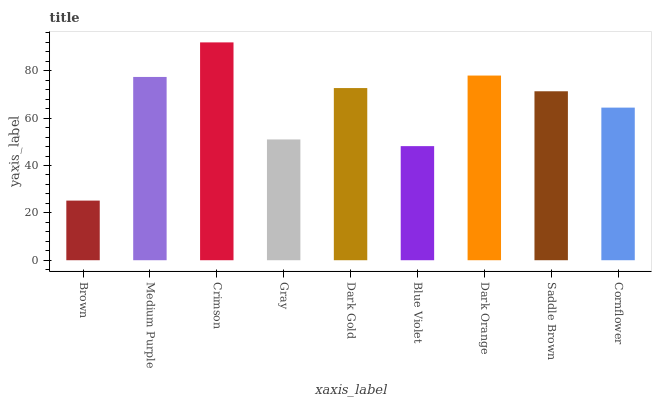Is Brown the minimum?
Answer yes or no. Yes. Is Crimson the maximum?
Answer yes or no. Yes. Is Medium Purple the minimum?
Answer yes or no. No. Is Medium Purple the maximum?
Answer yes or no. No. Is Medium Purple greater than Brown?
Answer yes or no. Yes. Is Brown less than Medium Purple?
Answer yes or no. Yes. Is Brown greater than Medium Purple?
Answer yes or no. No. Is Medium Purple less than Brown?
Answer yes or no. No. Is Saddle Brown the high median?
Answer yes or no. Yes. Is Saddle Brown the low median?
Answer yes or no. Yes. Is Dark Gold the high median?
Answer yes or no. No. Is Dark Orange the low median?
Answer yes or no. No. 